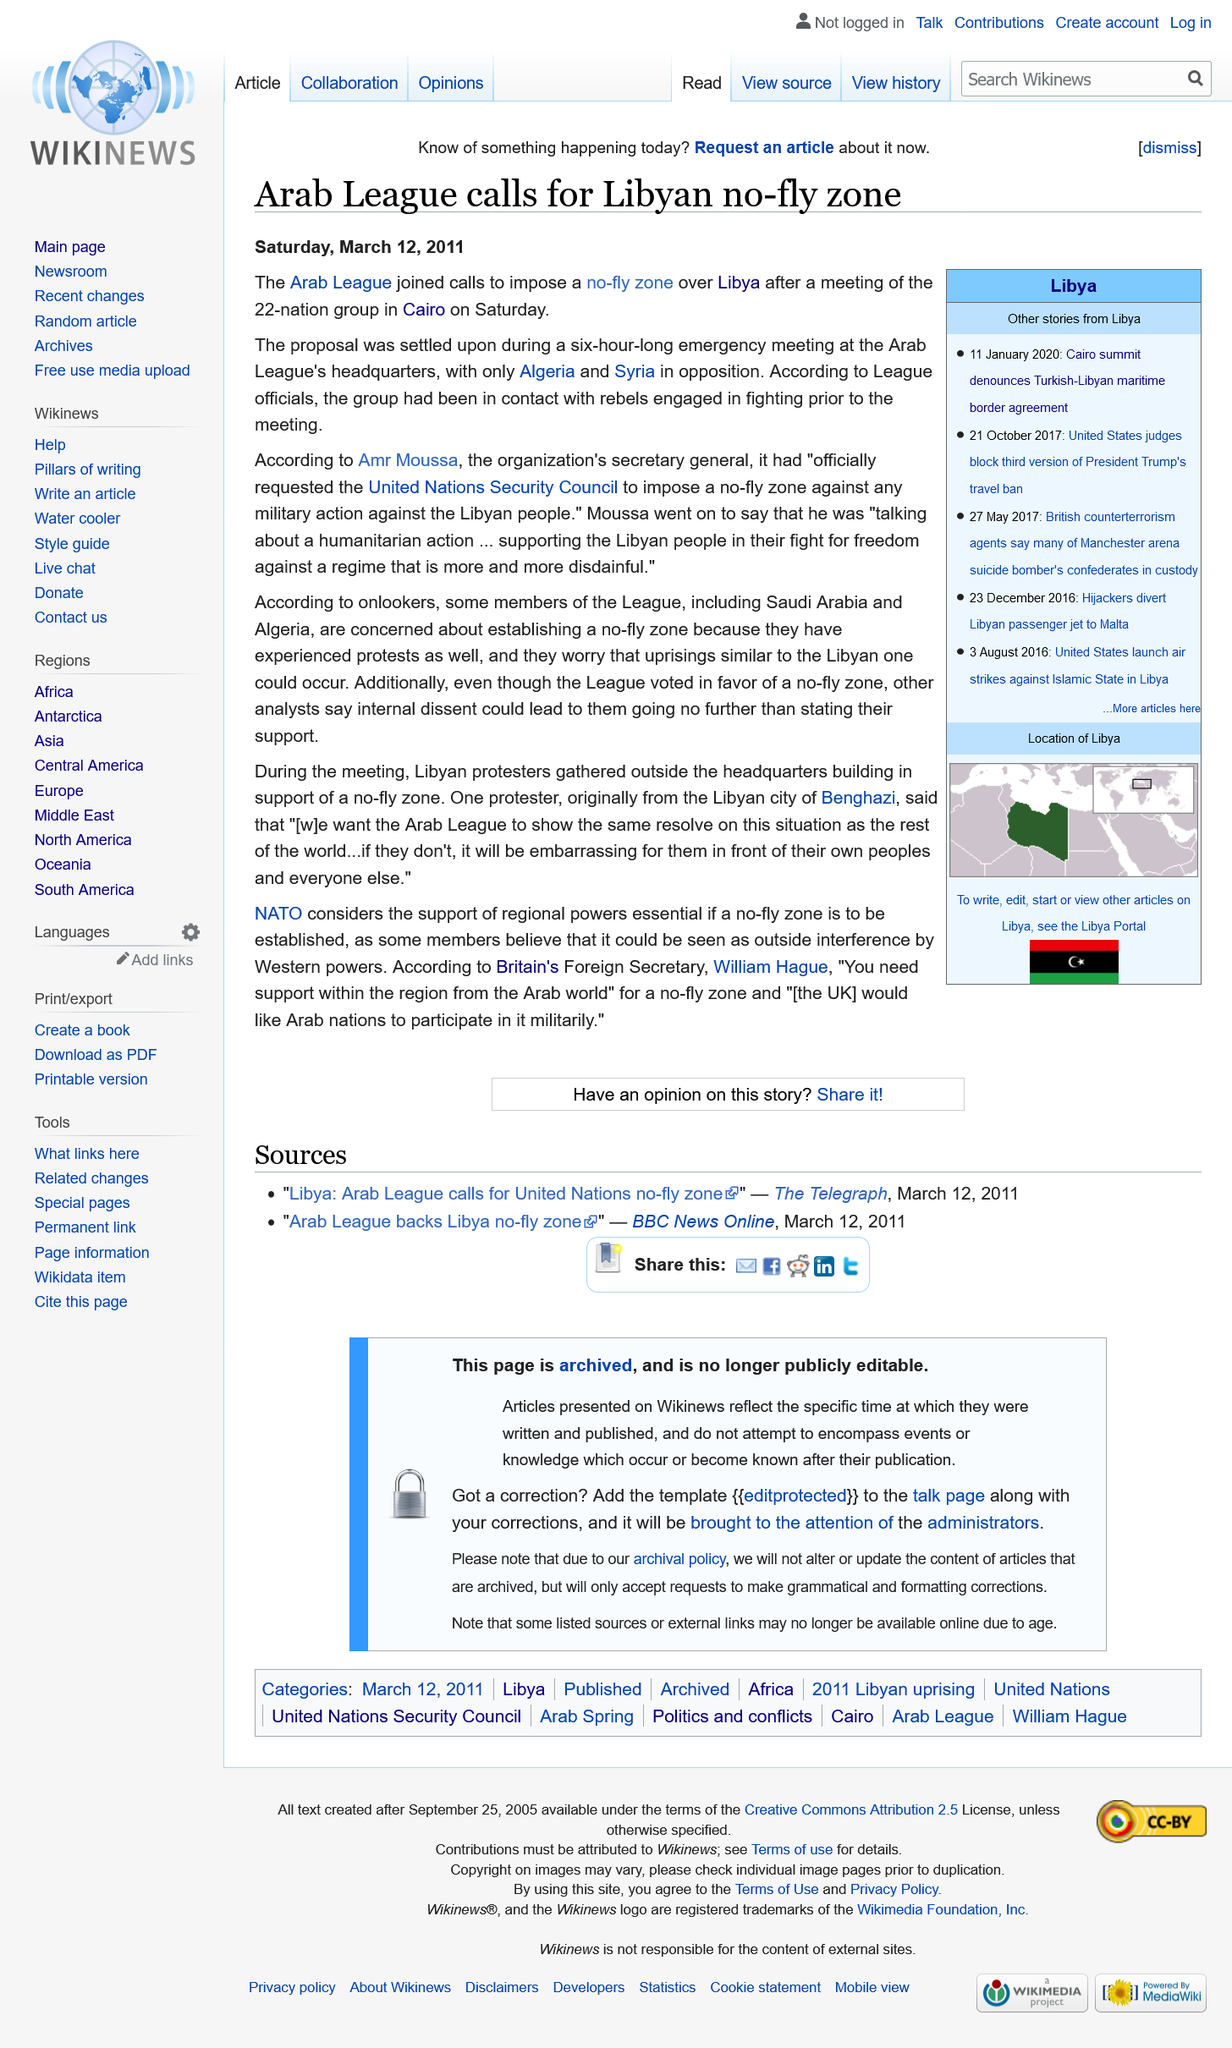Give some essential details in this illustration. Amr Moussa is the Secretary General of the organization. The Arab League has called for a Libyan no-fly zone. The Arab League, a 22-member organization, held a meeting in Cairo on Saturday, during which the number of its members was discussed. 